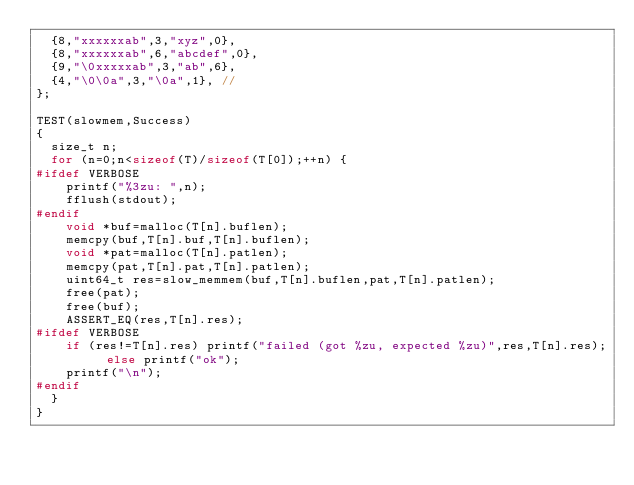Convert code to text. <code><loc_0><loc_0><loc_500><loc_500><_C++_>  {8,"xxxxxxab",3,"xyz",0},
  {8,"xxxxxxab",6,"abcdef",0},
  {9,"\0xxxxxab",3,"ab",6},
  {4,"\0\0a",3,"\0a",1}, //
};

TEST(slowmem,Success)
{
  size_t n;
  for (n=0;n<sizeof(T)/sizeof(T[0]);++n) {
#ifdef VERBOSE
    printf("%3zu: ",n);
    fflush(stdout);
#endif
    void *buf=malloc(T[n].buflen);
    memcpy(buf,T[n].buf,T[n].buflen);
    void *pat=malloc(T[n].patlen);
    memcpy(pat,T[n].pat,T[n].patlen);
    uint64_t res=slow_memmem(buf,T[n].buflen,pat,T[n].patlen);
    free(pat);
    free(buf);
    ASSERT_EQ(res,T[n].res);
#ifdef VERBOSE
    if (res!=T[n].res) printf("failed (got %zu, expected %zu)",res,T[n].res); else printf("ok");
    printf("\n");
#endif
  }
}
</code> 